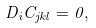Convert formula to latex. <formula><loc_0><loc_0><loc_500><loc_500>D _ { i } C _ { j k l } = 0 ,</formula> 